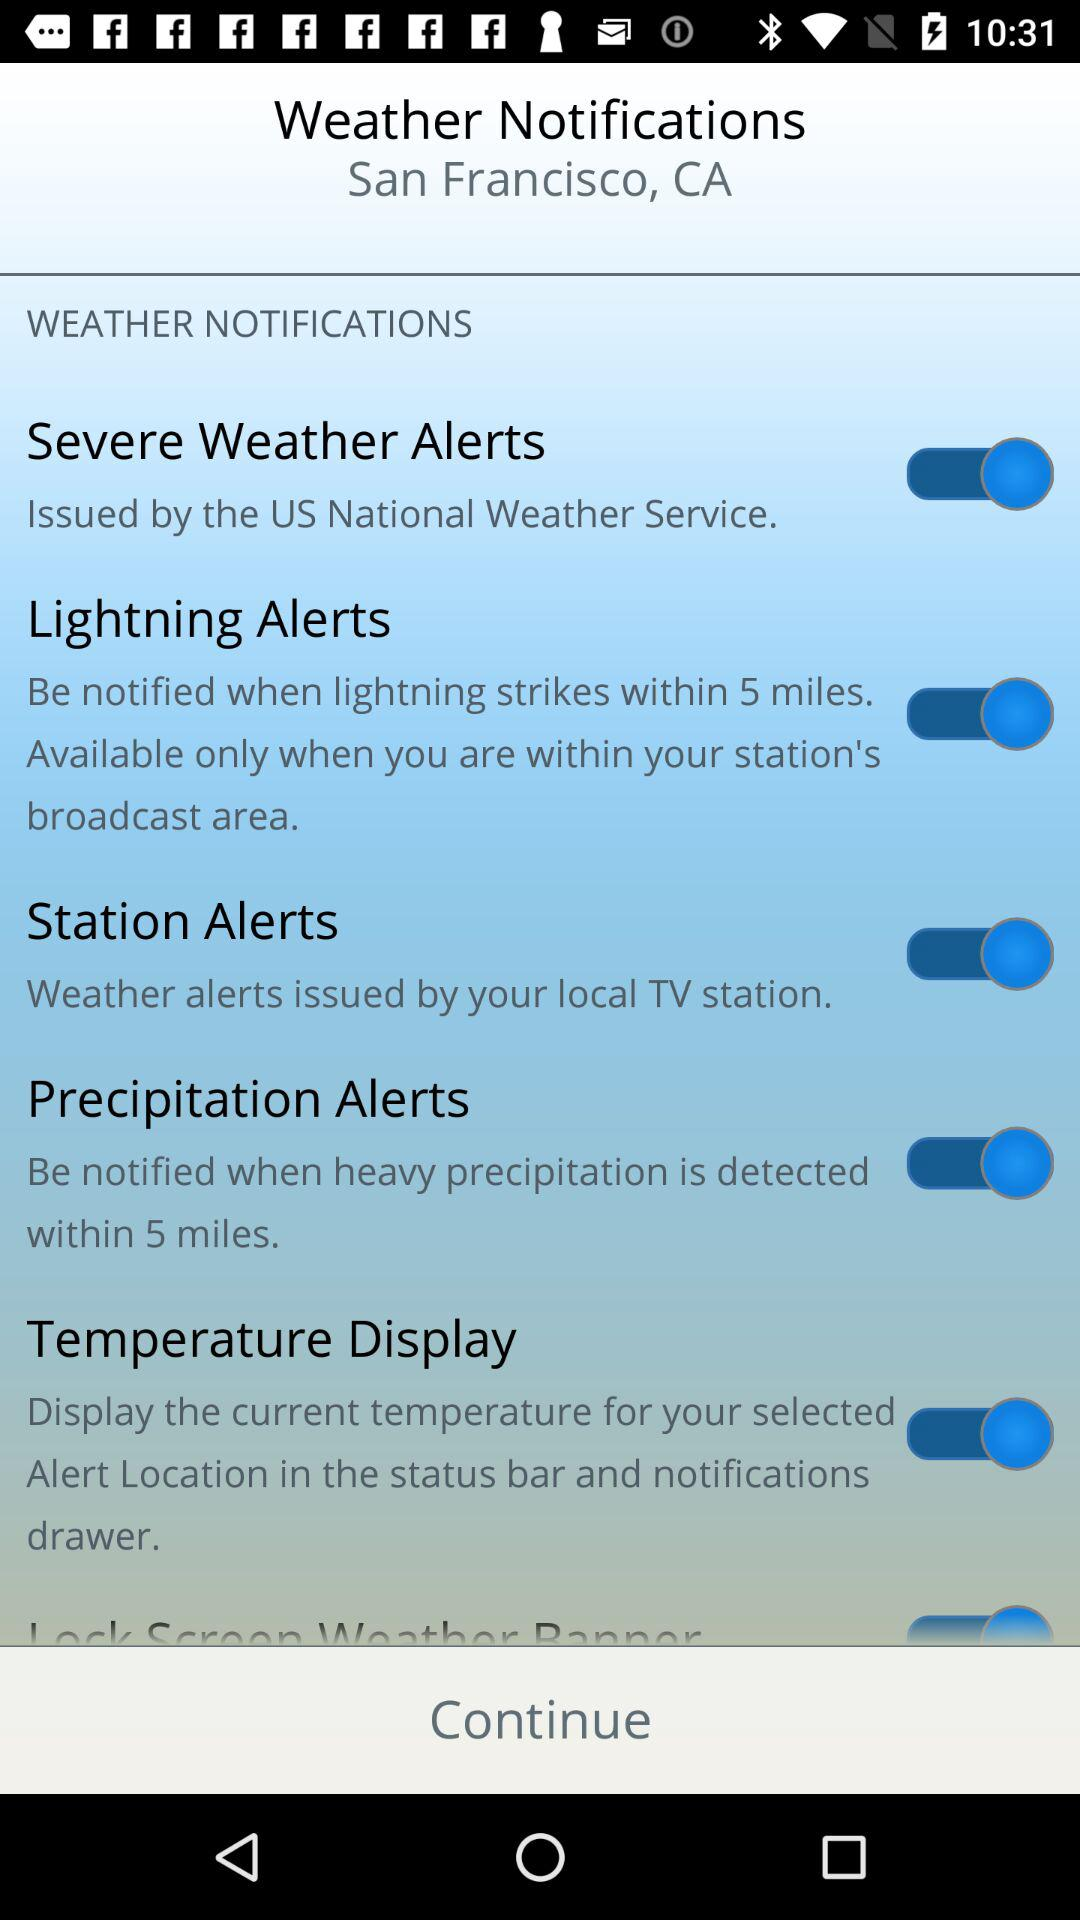Which city's name is displayed on the screen? The city's name is San Francisco. 